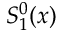<formula> <loc_0><loc_0><loc_500><loc_500>S _ { 1 } ^ { 0 } ( x )</formula> 